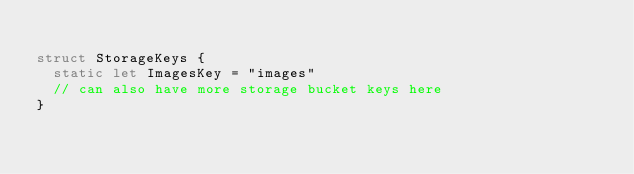<code> <loc_0><loc_0><loc_500><loc_500><_Swift_>
struct StorageKeys {
  static let ImagesKey = "images"
  // can also have more storage bucket keys here
}
</code> 